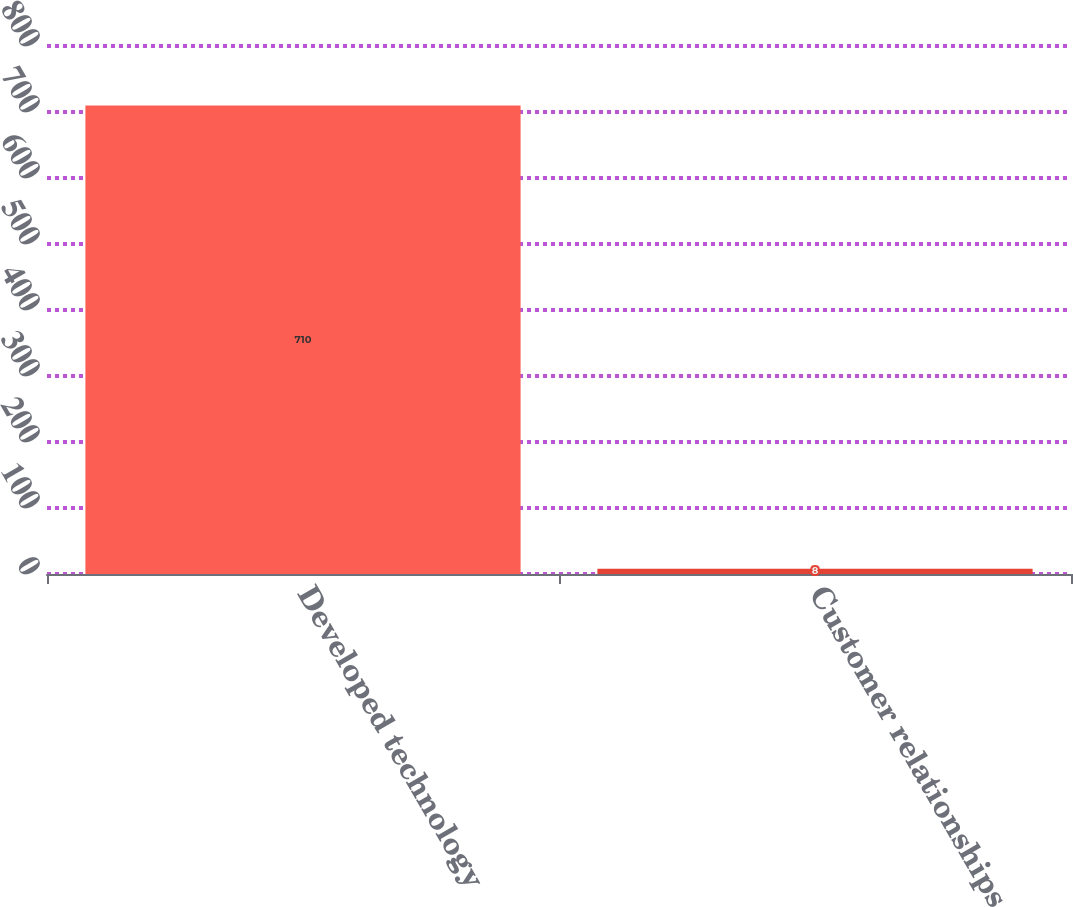Convert chart to OTSL. <chart><loc_0><loc_0><loc_500><loc_500><bar_chart><fcel>Developed technology<fcel>Customer relationships<nl><fcel>710<fcel>8<nl></chart> 